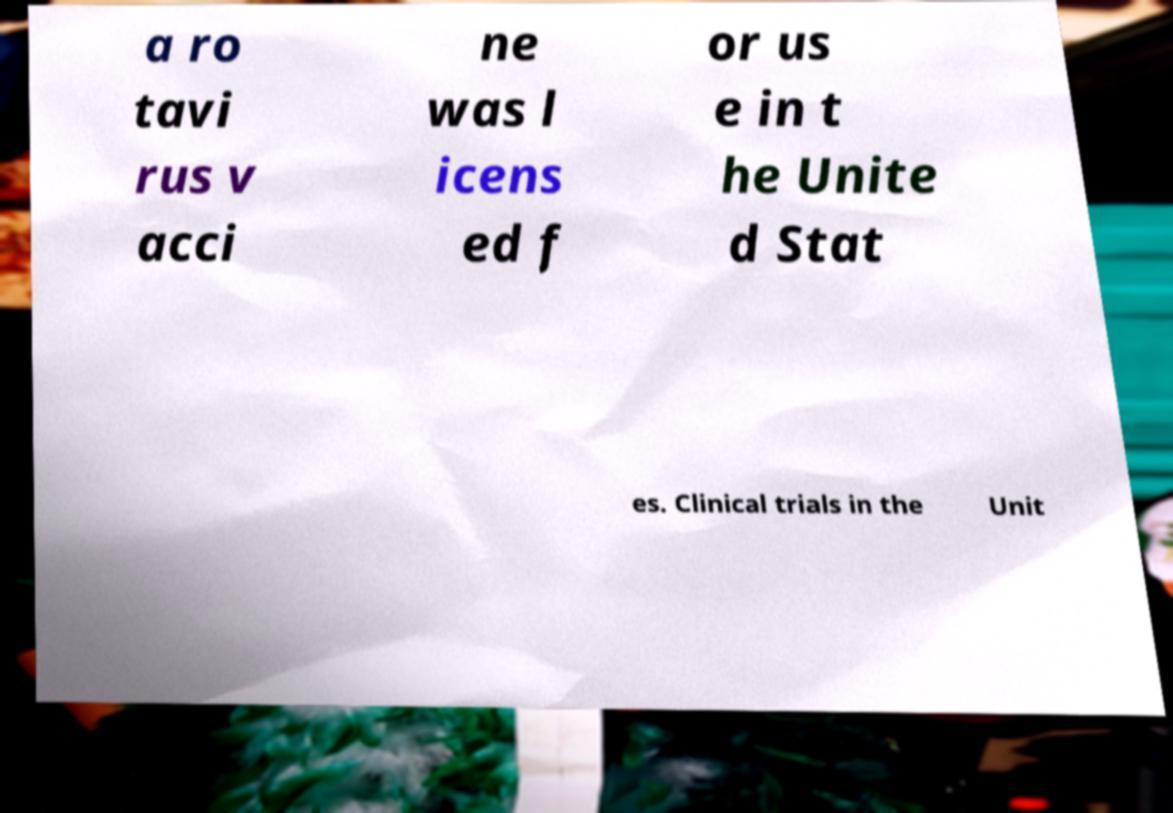Please identify and transcribe the text found in this image. a ro tavi rus v acci ne was l icens ed f or us e in t he Unite d Stat es. Clinical trials in the Unit 